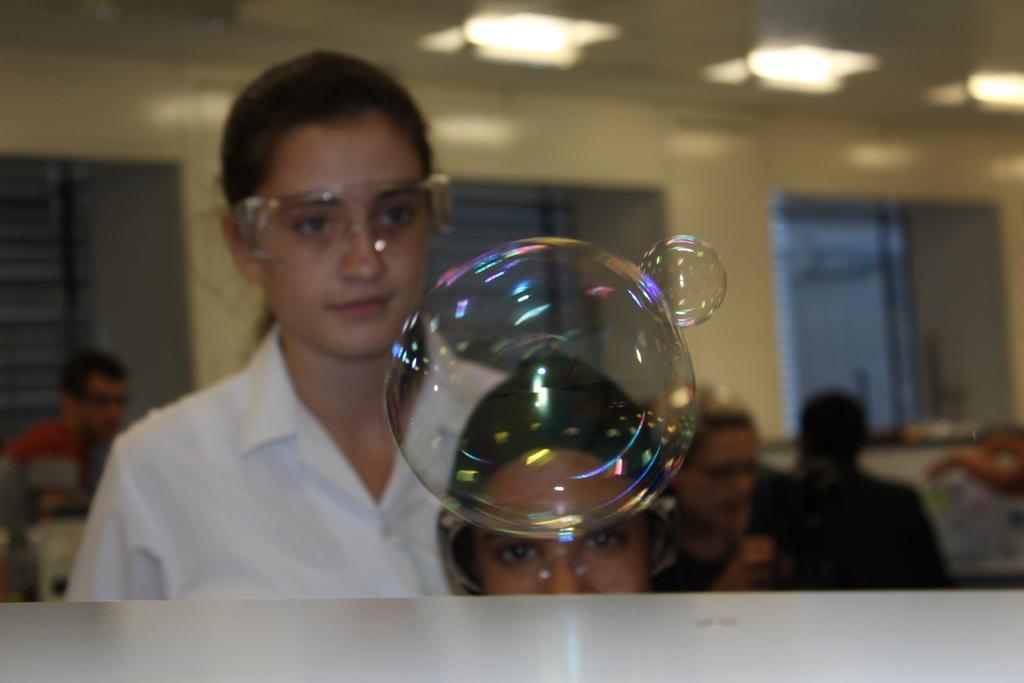In one or two sentences, can you explain what this image depicts? In this picture there is a woman who is wearing goggle and shirt. Beside her there is another person who is wearing cap and goggle. In front of them i can see the bubbles and table. In the background i can see some peoples were sitting on the chair near to the table. In the background i can see the windows and window blind. At the top i can see the lights which are hanging from the roof. 